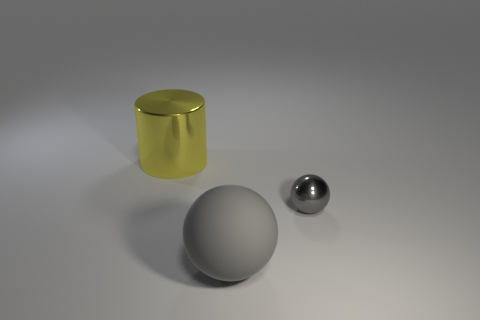Add 1 yellow cylinders. How many objects exist? 4 Subtract all big cylinders. Subtract all blue rubber cylinders. How many objects are left? 2 Add 3 tiny metal objects. How many tiny metal objects are left? 4 Add 1 small brown things. How many small brown things exist? 1 Subtract 0 green spheres. How many objects are left? 3 Subtract all balls. How many objects are left? 1 Subtract all green cylinders. Subtract all blue spheres. How many cylinders are left? 1 